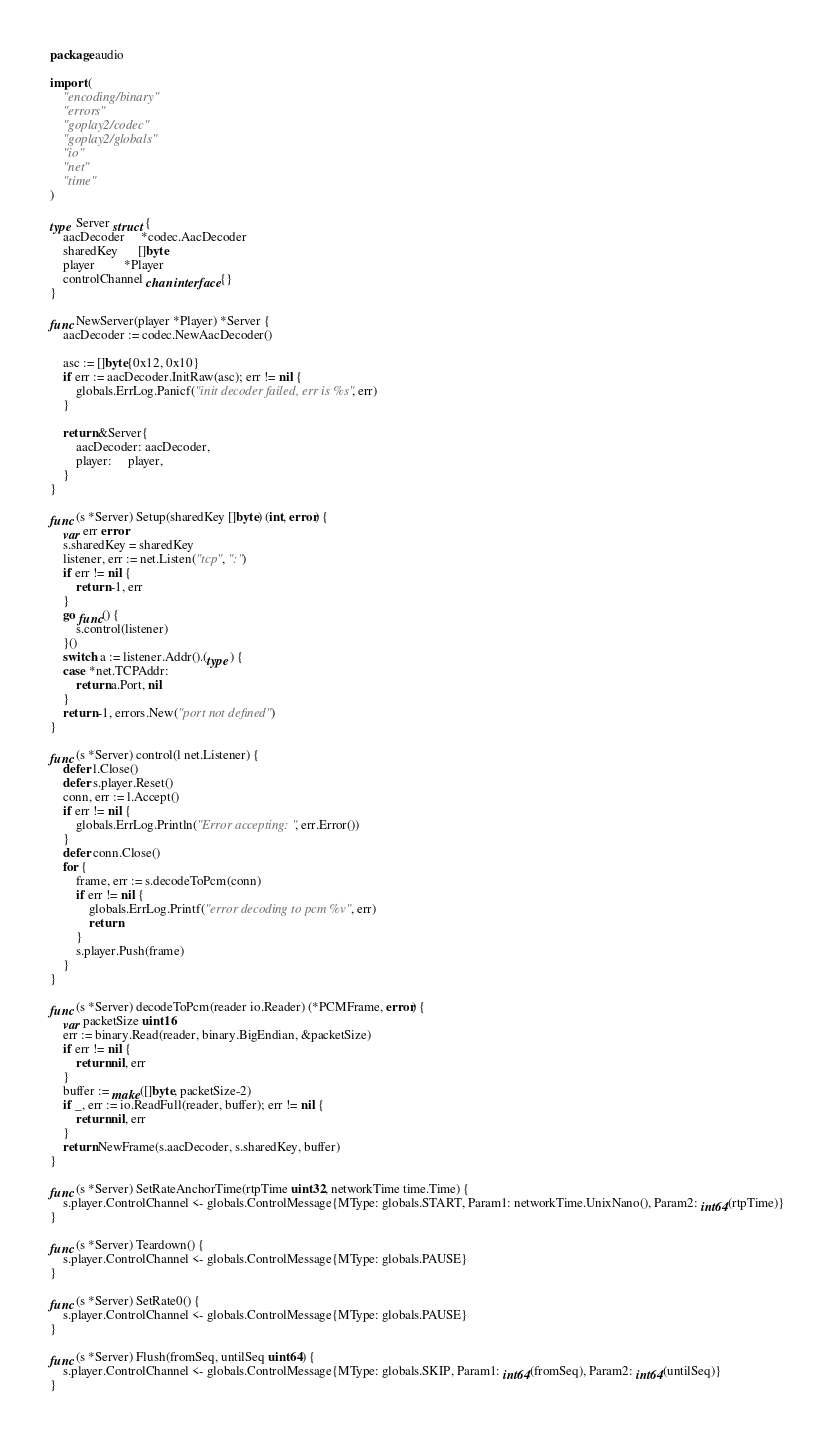<code> <loc_0><loc_0><loc_500><loc_500><_Go_>package audio

import (
	"encoding/binary"
	"errors"
	"goplay2/codec"
	"goplay2/globals"
	"io"
	"net"
	"time"
)

type Server struct {
	aacDecoder     *codec.AacDecoder
	sharedKey      []byte
	player         *Player
	controlChannel chan interface{}
}

func NewServer(player *Player) *Server {
	aacDecoder := codec.NewAacDecoder()

	asc := []byte{0x12, 0x10}
	if err := aacDecoder.InitRaw(asc); err != nil {
		globals.ErrLog.Panicf("init decoder failed, err is %s", err)
	}

	return &Server{
		aacDecoder: aacDecoder,
		player:     player,
	}
}

func (s *Server) Setup(sharedKey []byte) (int, error) {
	var err error
	s.sharedKey = sharedKey
	listener, err := net.Listen("tcp", ":")
	if err != nil {
		return -1, err
	}
	go func() {
		s.control(listener)
	}()
	switch a := listener.Addr().(type) {
	case *net.TCPAddr:
		return a.Port, nil
	}
	return -1, errors.New("port not defined")
}

func (s *Server) control(l net.Listener) {
	defer l.Close()
	defer s.player.Reset()
	conn, err := l.Accept()
	if err != nil {
		globals.ErrLog.Println("Error accepting: ", err.Error())
	}
	defer conn.Close()
	for {
		frame, err := s.decodeToPcm(conn)
		if err != nil {
			globals.ErrLog.Printf("error decoding to pcm %v", err)
			return
		}
		s.player.Push(frame)
	}
}

func (s *Server) decodeToPcm(reader io.Reader) (*PCMFrame, error) {
	var packetSize uint16
	err := binary.Read(reader, binary.BigEndian, &packetSize)
	if err != nil {
		return nil, err
	}
	buffer := make([]byte, packetSize-2)
	if _, err := io.ReadFull(reader, buffer); err != nil {
		return nil, err
	}
	return NewFrame(s.aacDecoder, s.sharedKey, buffer)
}

func (s *Server) SetRateAnchorTime(rtpTime uint32, networkTime time.Time) {
	s.player.ControlChannel <- globals.ControlMessage{MType: globals.START, Param1: networkTime.UnixNano(), Param2: int64(rtpTime)}
}

func (s *Server) Teardown() {
	s.player.ControlChannel <- globals.ControlMessage{MType: globals.PAUSE}
}

func (s *Server) SetRate0() {
	s.player.ControlChannel <- globals.ControlMessage{MType: globals.PAUSE}
}

func (s *Server) Flush(fromSeq, untilSeq uint64) {
	s.player.ControlChannel <- globals.ControlMessage{MType: globals.SKIP, Param1: int64(fromSeq), Param2: int64(untilSeq)}
}
</code> 